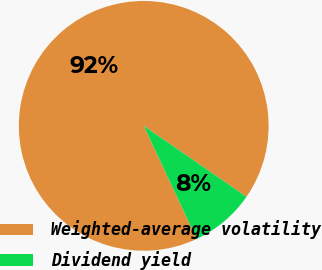<chart> <loc_0><loc_0><loc_500><loc_500><pie_chart><fcel>Weighted-average volatility<fcel>Dividend yield<nl><fcel>91.6%<fcel>8.4%<nl></chart> 